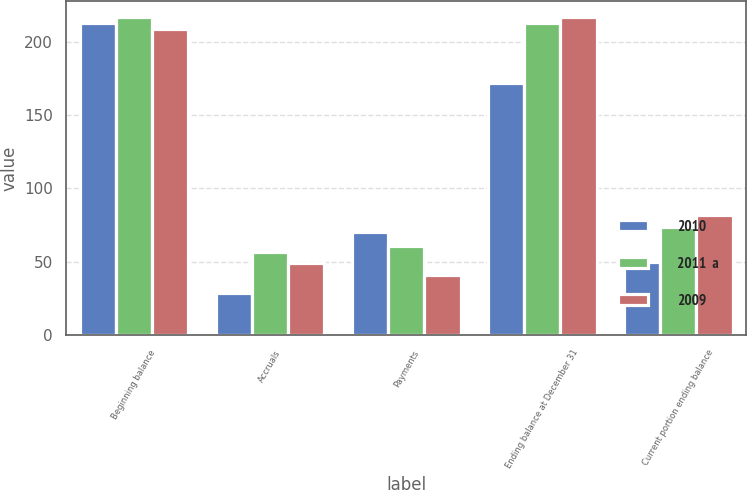Convert chart. <chart><loc_0><loc_0><loc_500><loc_500><stacked_bar_chart><ecel><fcel>Beginning balance<fcel>Accruals<fcel>Payments<fcel>Ending balance at December 31<fcel>Current portion ending balance<nl><fcel>2010<fcel>213<fcel>29<fcel>70<fcel>172<fcel>50<nl><fcel>2011  a<fcel>217<fcel>57<fcel>61<fcel>213<fcel>74<nl><fcel>2009<fcel>209<fcel>49<fcel>41<fcel>217<fcel>82<nl></chart> 